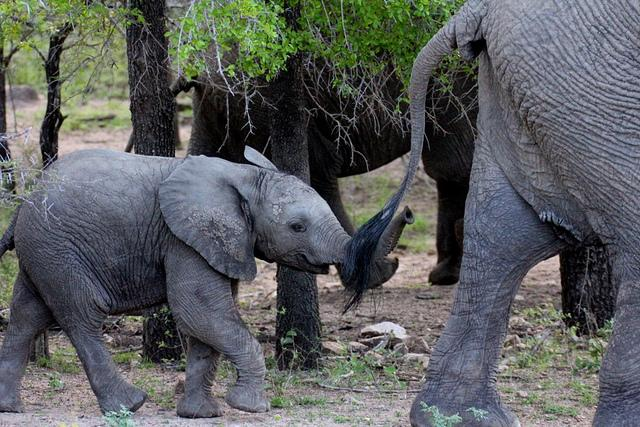Whos is the little elephant likely following? mother 